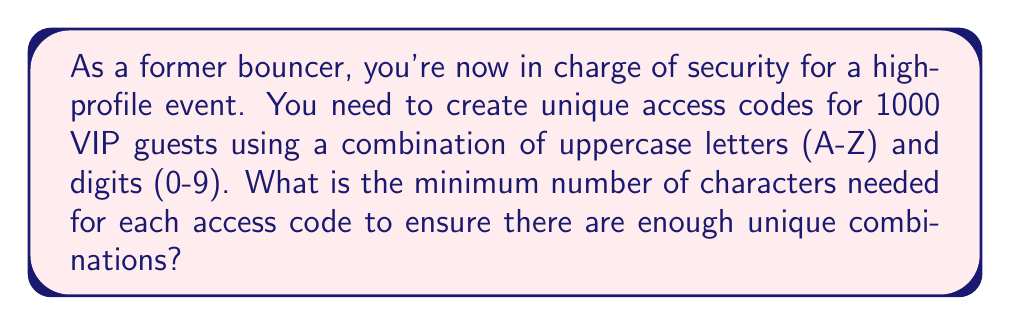Show me your answer to this math problem. Let's approach this step-by-step:

1) First, we need to calculate the total number of possible characters:
   - 26 uppercase letters (A-Z)
   - 10 digits (0-9)
   Total: 26 + 10 = 36 characters

2) Now, we need to find the minimum length $n$ such that $36^n \geq 1000$, where:
   - 36 is the number of possible characters for each position
   - $n$ is the number of characters in the code
   - 1000 is the minimum number of unique codes needed

3) We can solve this using logarithms:

   $$36^n \geq 1000$$
   $$\log_{36}(36^n) \geq \log_{36}(1000)$$
   $$n \geq \log_{36}(1000)$$

4) Calculate $\log_{36}(1000)$:
   
   $$\log_{36}(1000) = \frac{\log(1000)}{\log(36)} \approx 3.984$$

5) Since $n$ must be a whole number, we round up to the nearest integer:

   $$n = \lceil 3.984 \rceil = 4$$

Therefore, we need a minimum of 4 characters for each access code.

6) Verify: $36^4 = 1,679,616$, which is indeed greater than 1000.
Answer: 4 characters 